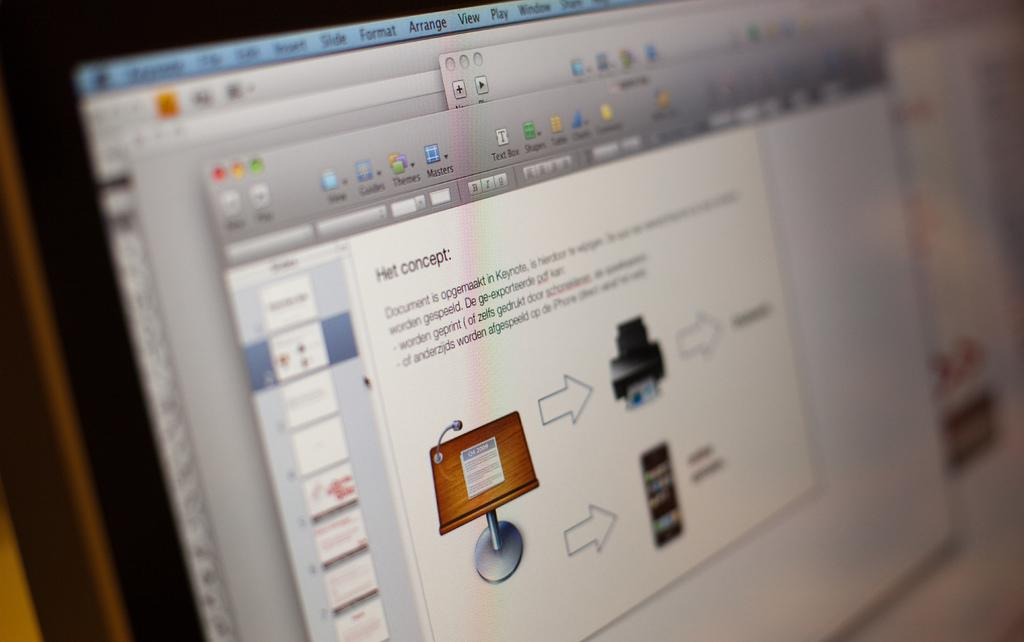<image>
Create a compact narrative representing the image presented. A computer screen has a slide maker open and talking about the Het concept. 